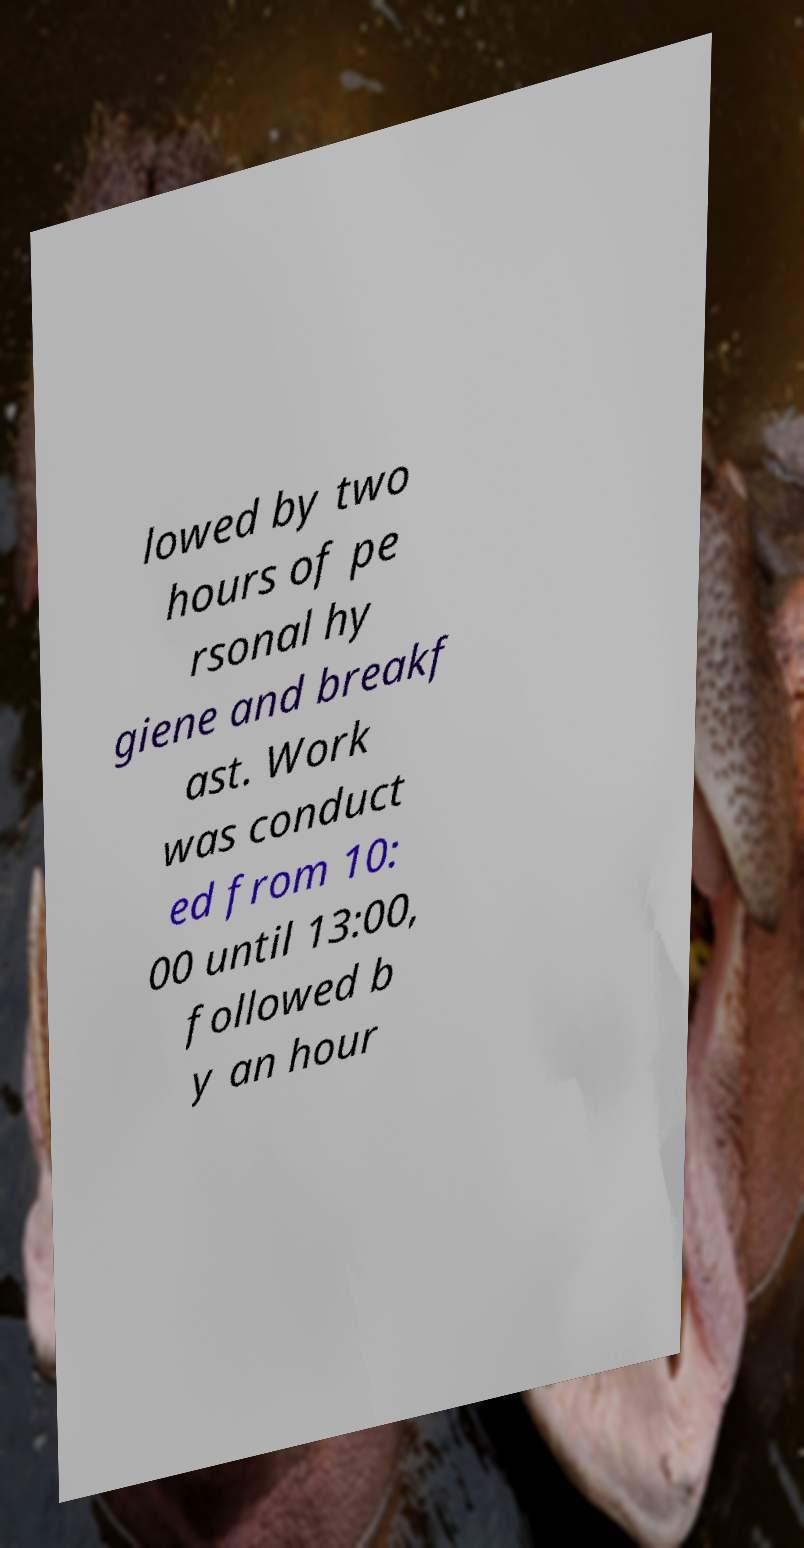Can you read and provide the text displayed in the image?This photo seems to have some interesting text. Can you extract and type it out for me? lowed by two hours of pe rsonal hy giene and breakf ast. Work was conduct ed from 10: 00 until 13:00, followed b y an hour 